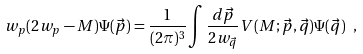Convert formula to latex. <formula><loc_0><loc_0><loc_500><loc_500>w _ { p } ( 2 w _ { p } - M ) \Psi ( \vec { p } ) = \frac { 1 } { ( 2 \pi ) ^ { 3 } } \int \frac { d \vec { p } } { 2 w _ { \vec { q } } } V ( M ; \vec { p } , \vec { q } ) \Psi ( \vec { q } ) \ ,</formula> 